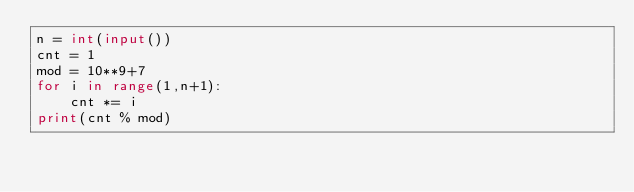<code> <loc_0><loc_0><loc_500><loc_500><_Python_>n = int(input())
cnt = 1
mod = 10**9+7
for i in range(1,n+1):
    cnt *= i
print(cnt % mod)</code> 